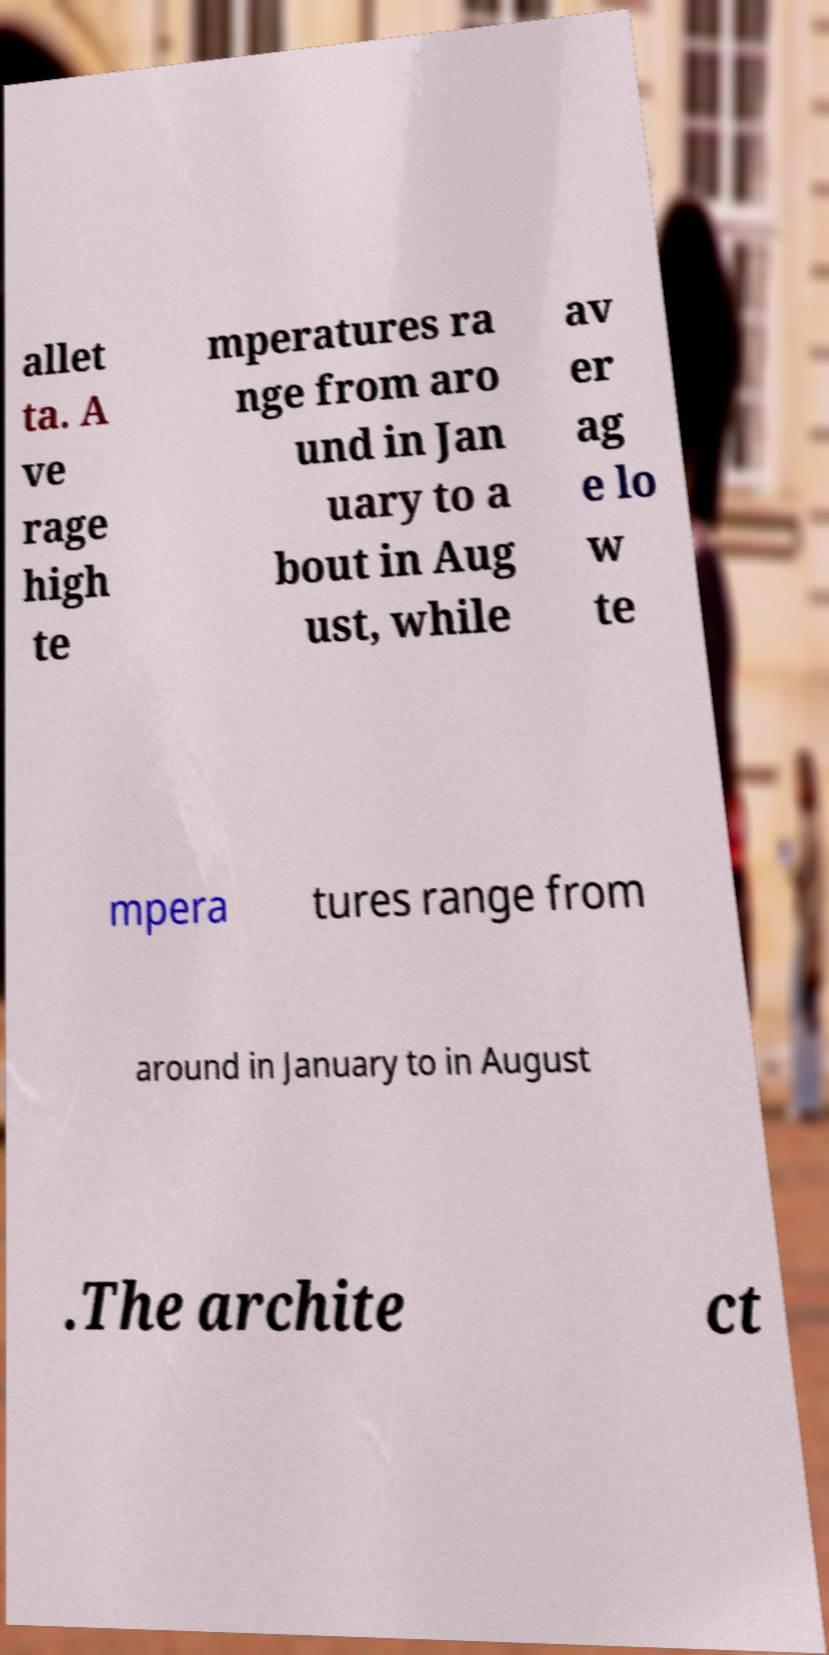I need the written content from this picture converted into text. Can you do that? allet ta. A ve rage high te mperatures ra nge from aro und in Jan uary to a bout in Aug ust, while av er ag e lo w te mpera tures range from around in January to in August .The archite ct 